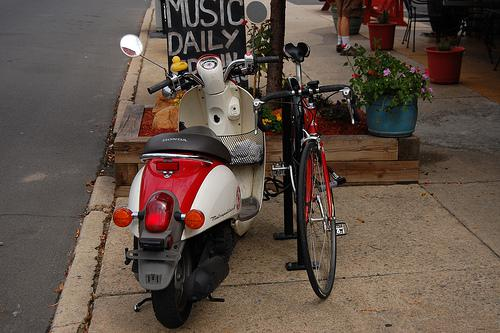Question: how many flower pots are there?
Choices:
A. One.
B. Two.
C. Five.
D. Three.
Answer with the letter. Answer: D Question: where is the scooter?
Choices:
A. Street.
B. Grass.
C. Sidewalk.
D. Nowhere.
Answer with the letter. Answer: C Question: where was the photo taken?
Choices:
A. In the street.
B. In the park.
C. On the sidewalk.
D. At the playground.
Answer with the letter. Answer: C 